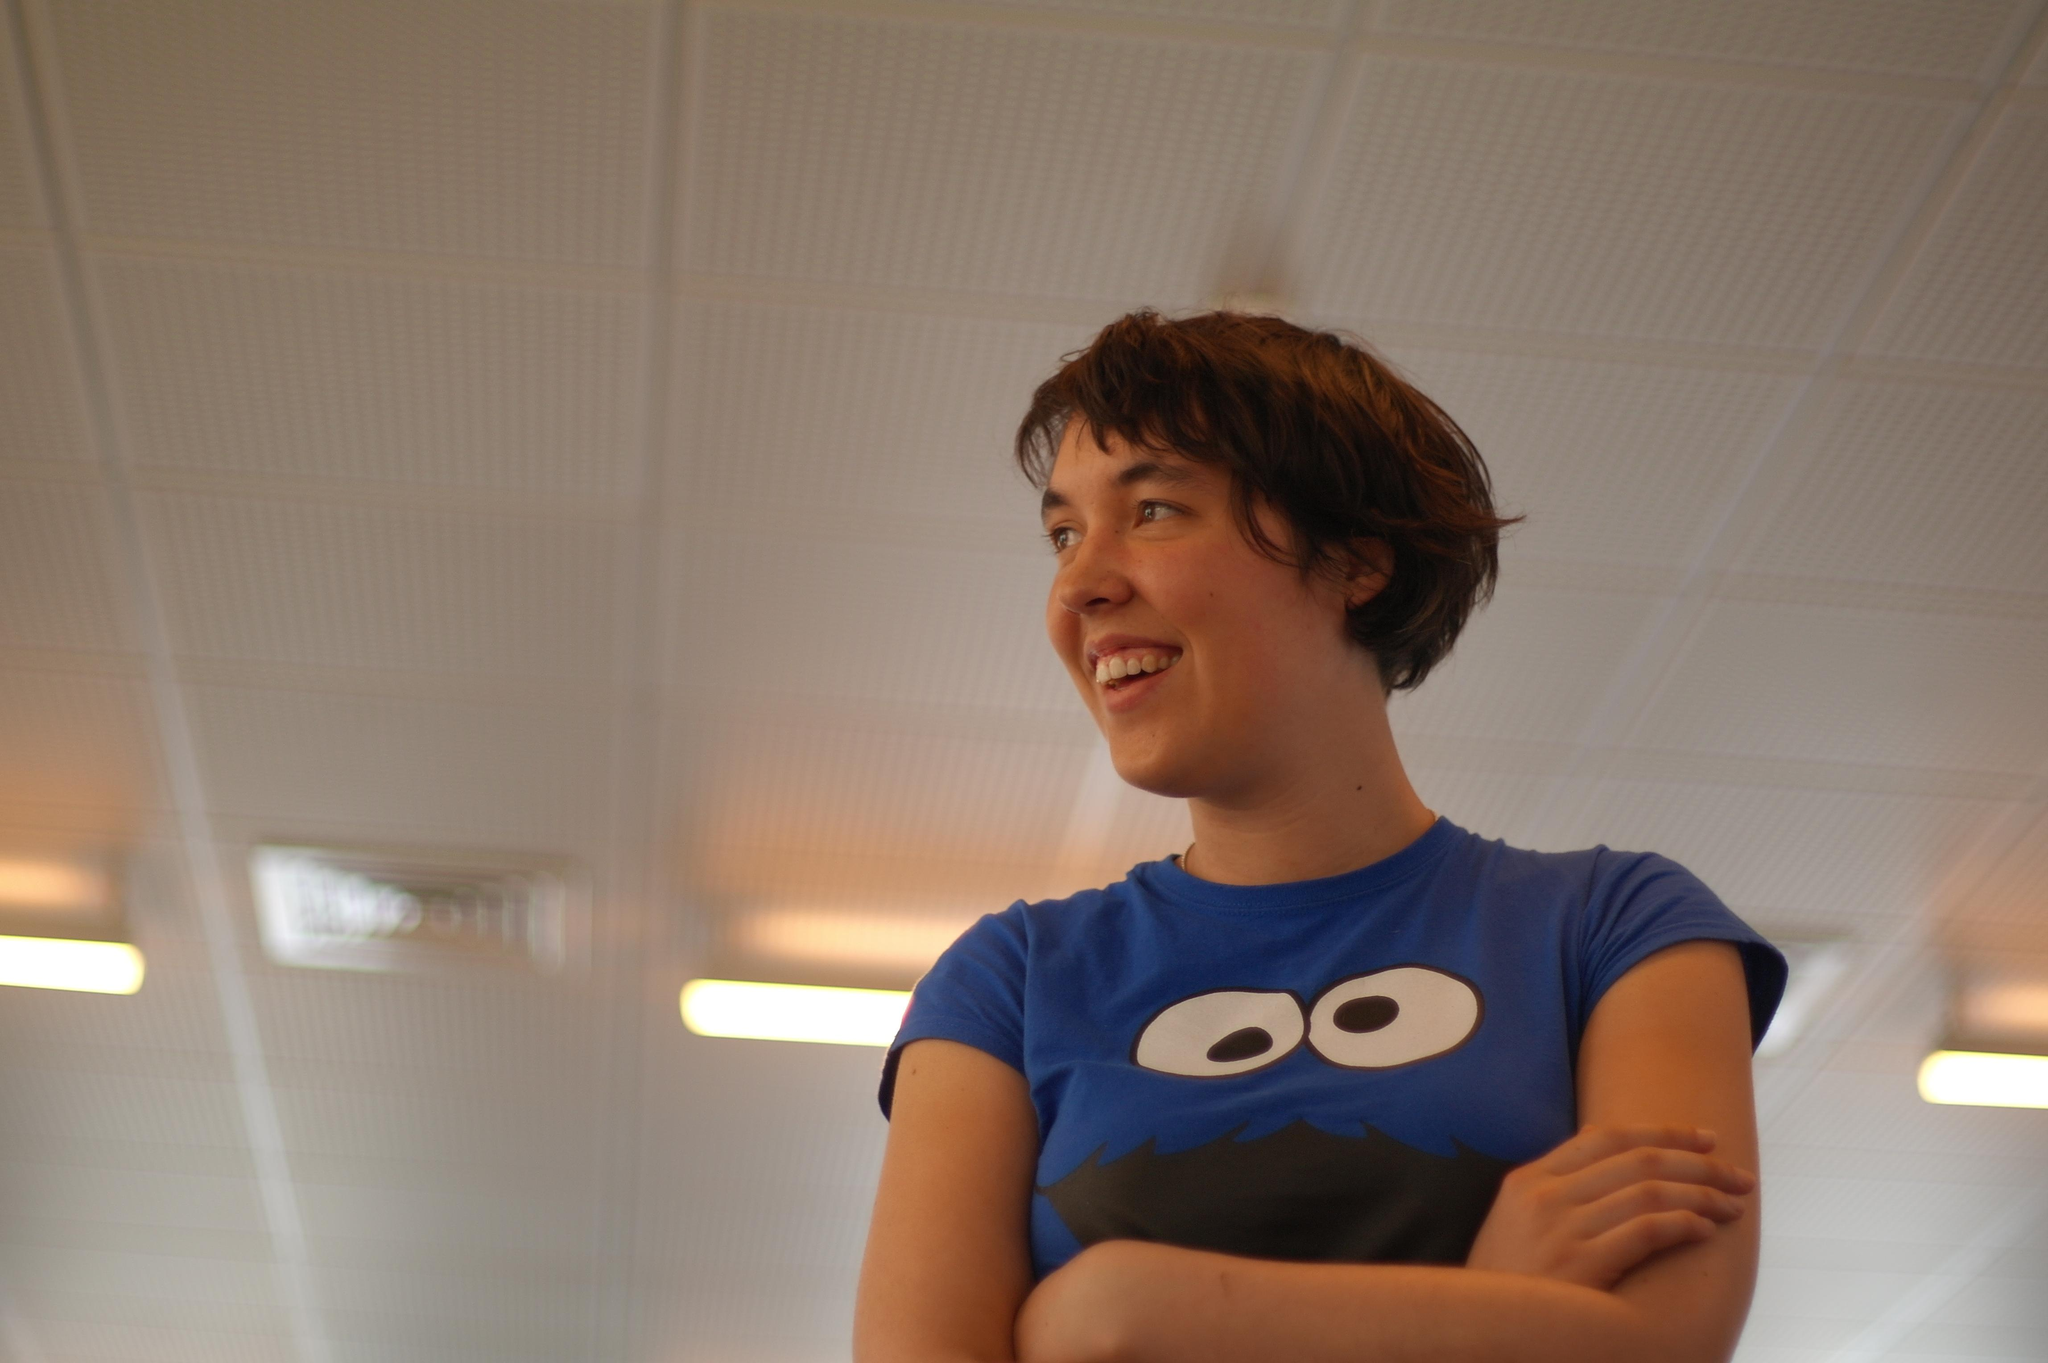Who or what is present in the image? There is a person in the image. What is the person wearing? The person is wearing a blue, black, and white t-shirt. What can be seen in the background of the image? There is a ceiling visible in the background of the image, and lights are attached to the ceiling. What type of whistle can be heard in the image? There is no whistle present in the image, and therefore no sound can be heard. 